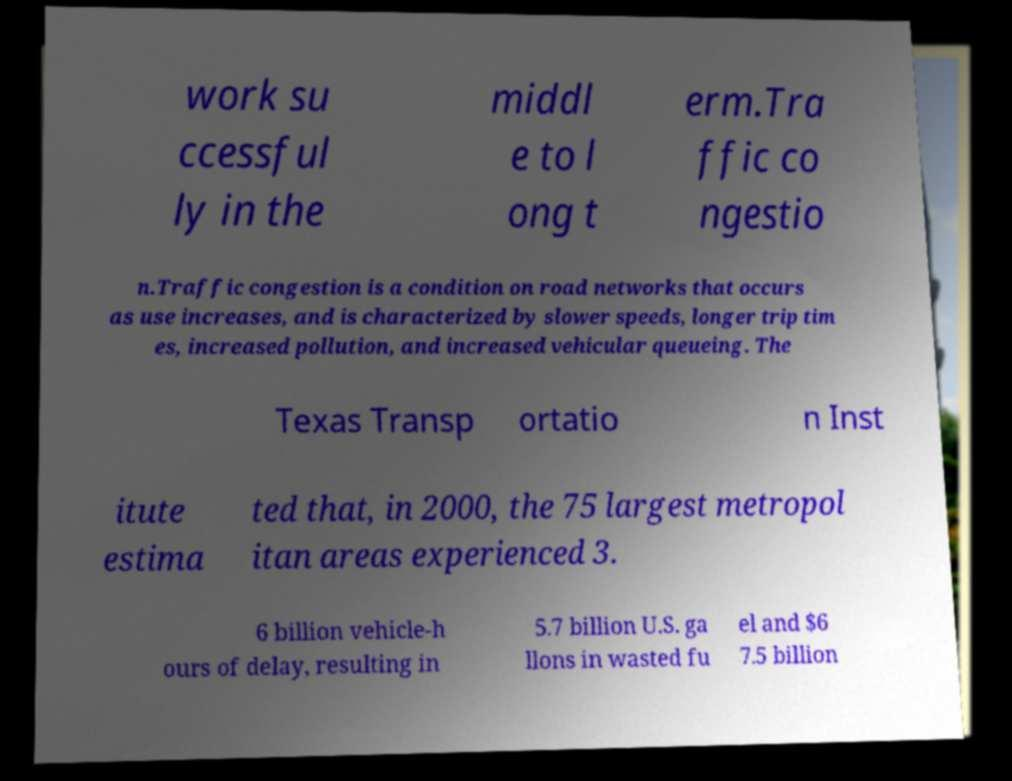Could you extract and type out the text from this image? work su ccessful ly in the middl e to l ong t erm.Tra ffic co ngestio n.Traffic congestion is a condition on road networks that occurs as use increases, and is characterized by slower speeds, longer trip tim es, increased pollution, and increased vehicular queueing. The Texas Transp ortatio n Inst itute estima ted that, in 2000, the 75 largest metropol itan areas experienced 3. 6 billion vehicle-h ours of delay, resulting in 5.7 billion U.S. ga llons in wasted fu el and $6 7.5 billion 